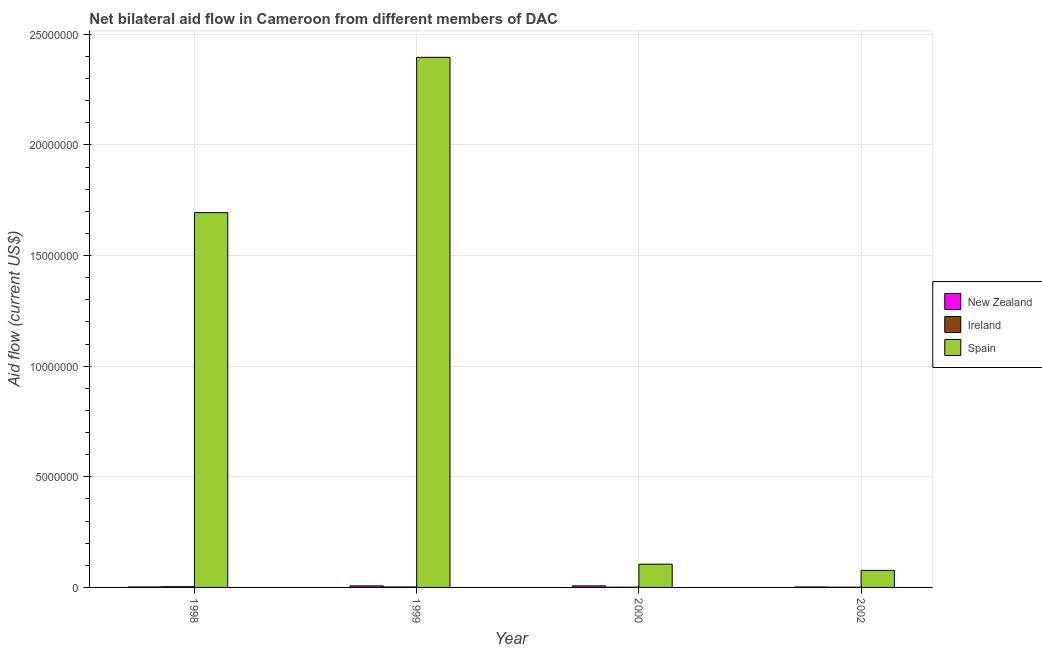How many different coloured bars are there?
Your answer should be compact. 3. How many bars are there on the 4th tick from the left?
Your answer should be compact. 3. In how many cases, is the number of bars for a given year not equal to the number of legend labels?
Your answer should be very brief. 0. What is the amount of aid provided by new zealand in 2000?
Keep it short and to the point. 7.00e+04. Across all years, what is the maximum amount of aid provided by new zealand?
Make the answer very short. 7.00e+04. Across all years, what is the minimum amount of aid provided by ireland?
Keep it short and to the point. 10000. In which year was the amount of aid provided by spain maximum?
Offer a terse response. 1999. What is the total amount of aid provided by new zealand in the graph?
Provide a succinct answer. 1.80e+05. What is the difference between the amount of aid provided by ireland in 2000 and that in 2002?
Keep it short and to the point. 0. What is the difference between the amount of aid provided by ireland in 1999 and the amount of aid provided by new zealand in 2002?
Your response must be concise. 10000. What is the average amount of aid provided by spain per year?
Provide a succinct answer. 1.07e+07. In the year 1998, what is the difference between the amount of aid provided by ireland and amount of aid provided by new zealand?
Ensure brevity in your answer.  0. In how many years, is the amount of aid provided by new zealand greater than 1000000 US$?
Your answer should be compact. 0. What is the ratio of the amount of aid provided by spain in 1998 to that in 2002?
Provide a short and direct response. 22. What is the difference between the highest and the lowest amount of aid provided by new zealand?
Provide a succinct answer. 5.00e+04. In how many years, is the amount of aid provided by new zealand greater than the average amount of aid provided by new zealand taken over all years?
Offer a terse response. 2. Is the sum of the amount of aid provided by ireland in 1999 and 2000 greater than the maximum amount of aid provided by spain across all years?
Your answer should be very brief. No. What does the 1st bar from the left in 1998 represents?
Keep it short and to the point. New Zealand. What does the 1st bar from the right in 2002 represents?
Ensure brevity in your answer.  Spain. Is it the case that in every year, the sum of the amount of aid provided by new zealand and amount of aid provided by ireland is greater than the amount of aid provided by spain?
Ensure brevity in your answer.  No. Are all the bars in the graph horizontal?
Your answer should be very brief. No. What is the difference between two consecutive major ticks on the Y-axis?
Your answer should be very brief. 5.00e+06. Are the values on the major ticks of Y-axis written in scientific E-notation?
Your answer should be compact. No. Where does the legend appear in the graph?
Provide a succinct answer. Center right. What is the title of the graph?
Keep it short and to the point. Net bilateral aid flow in Cameroon from different members of DAC. What is the Aid flow (current US$) in New Zealand in 1998?
Provide a short and direct response. 2.00e+04. What is the Aid flow (current US$) of Spain in 1998?
Offer a terse response. 1.69e+07. What is the Aid flow (current US$) of Ireland in 1999?
Offer a very short reply. 2.00e+04. What is the Aid flow (current US$) of Spain in 1999?
Keep it short and to the point. 2.40e+07. What is the Aid flow (current US$) in New Zealand in 2000?
Provide a short and direct response. 7.00e+04. What is the Aid flow (current US$) in Spain in 2000?
Offer a very short reply. 1.05e+06. What is the Aid flow (current US$) in Spain in 2002?
Your answer should be compact. 7.70e+05. Across all years, what is the maximum Aid flow (current US$) in New Zealand?
Your response must be concise. 7.00e+04. Across all years, what is the maximum Aid flow (current US$) of Ireland?
Ensure brevity in your answer.  3.00e+04. Across all years, what is the maximum Aid flow (current US$) in Spain?
Offer a very short reply. 2.40e+07. Across all years, what is the minimum Aid flow (current US$) of New Zealand?
Your response must be concise. 2.00e+04. Across all years, what is the minimum Aid flow (current US$) in Spain?
Provide a short and direct response. 7.70e+05. What is the total Aid flow (current US$) in New Zealand in the graph?
Keep it short and to the point. 1.80e+05. What is the total Aid flow (current US$) in Spain in the graph?
Give a very brief answer. 4.27e+07. What is the difference between the Aid flow (current US$) of New Zealand in 1998 and that in 1999?
Your response must be concise. -5.00e+04. What is the difference between the Aid flow (current US$) in Ireland in 1998 and that in 1999?
Your response must be concise. 10000. What is the difference between the Aid flow (current US$) of Spain in 1998 and that in 1999?
Ensure brevity in your answer.  -7.02e+06. What is the difference between the Aid flow (current US$) of New Zealand in 1998 and that in 2000?
Provide a succinct answer. -5.00e+04. What is the difference between the Aid flow (current US$) of Ireland in 1998 and that in 2000?
Provide a succinct answer. 2.00e+04. What is the difference between the Aid flow (current US$) of Spain in 1998 and that in 2000?
Keep it short and to the point. 1.59e+07. What is the difference between the Aid flow (current US$) of Spain in 1998 and that in 2002?
Offer a very short reply. 1.62e+07. What is the difference between the Aid flow (current US$) of Ireland in 1999 and that in 2000?
Your answer should be very brief. 10000. What is the difference between the Aid flow (current US$) of Spain in 1999 and that in 2000?
Provide a short and direct response. 2.29e+07. What is the difference between the Aid flow (current US$) in New Zealand in 1999 and that in 2002?
Your answer should be compact. 5.00e+04. What is the difference between the Aid flow (current US$) in Spain in 1999 and that in 2002?
Your answer should be compact. 2.32e+07. What is the difference between the Aid flow (current US$) in Ireland in 2000 and that in 2002?
Provide a succinct answer. 0. What is the difference between the Aid flow (current US$) of Spain in 2000 and that in 2002?
Ensure brevity in your answer.  2.80e+05. What is the difference between the Aid flow (current US$) in New Zealand in 1998 and the Aid flow (current US$) in Ireland in 1999?
Offer a terse response. 0. What is the difference between the Aid flow (current US$) in New Zealand in 1998 and the Aid flow (current US$) in Spain in 1999?
Give a very brief answer. -2.39e+07. What is the difference between the Aid flow (current US$) of Ireland in 1998 and the Aid flow (current US$) of Spain in 1999?
Keep it short and to the point. -2.39e+07. What is the difference between the Aid flow (current US$) in New Zealand in 1998 and the Aid flow (current US$) in Ireland in 2000?
Provide a short and direct response. 10000. What is the difference between the Aid flow (current US$) in New Zealand in 1998 and the Aid flow (current US$) in Spain in 2000?
Keep it short and to the point. -1.03e+06. What is the difference between the Aid flow (current US$) in Ireland in 1998 and the Aid flow (current US$) in Spain in 2000?
Offer a terse response. -1.02e+06. What is the difference between the Aid flow (current US$) in New Zealand in 1998 and the Aid flow (current US$) in Spain in 2002?
Your answer should be very brief. -7.50e+05. What is the difference between the Aid flow (current US$) in Ireland in 1998 and the Aid flow (current US$) in Spain in 2002?
Give a very brief answer. -7.40e+05. What is the difference between the Aid flow (current US$) of New Zealand in 1999 and the Aid flow (current US$) of Ireland in 2000?
Your response must be concise. 6.00e+04. What is the difference between the Aid flow (current US$) in New Zealand in 1999 and the Aid flow (current US$) in Spain in 2000?
Ensure brevity in your answer.  -9.80e+05. What is the difference between the Aid flow (current US$) of Ireland in 1999 and the Aid flow (current US$) of Spain in 2000?
Ensure brevity in your answer.  -1.03e+06. What is the difference between the Aid flow (current US$) in New Zealand in 1999 and the Aid flow (current US$) in Spain in 2002?
Your answer should be compact. -7.00e+05. What is the difference between the Aid flow (current US$) of Ireland in 1999 and the Aid flow (current US$) of Spain in 2002?
Your answer should be compact. -7.50e+05. What is the difference between the Aid flow (current US$) of New Zealand in 2000 and the Aid flow (current US$) of Ireland in 2002?
Your answer should be very brief. 6.00e+04. What is the difference between the Aid flow (current US$) in New Zealand in 2000 and the Aid flow (current US$) in Spain in 2002?
Your response must be concise. -7.00e+05. What is the difference between the Aid flow (current US$) in Ireland in 2000 and the Aid flow (current US$) in Spain in 2002?
Offer a very short reply. -7.60e+05. What is the average Aid flow (current US$) in New Zealand per year?
Provide a succinct answer. 4.50e+04. What is the average Aid flow (current US$) of Ireland per year?
Your answer should be very brief. 1.75e+04. What is the average Aid flow (current US$) in Spain per year?
Your answer should be compact. 1.07e+07. In the year 1998, what is the difference between the Aid flow (current US$) of New Zealand and Aid flow (current US$) of Ireland?
Provide a short and direct response. -10000. In the year 1998, what is the difference between the Aid flow (current US$) in New Zealand and Aid flow (current US$) in Spain?
Ensure brevity in your answer.  -1.69e+07. In the year 1998, what is the difference between the Aid flow (current US$) in Ireland and Aid flow (current US$) in Spain?
Provide a succinct answer. -1.69e+07. In the year 1999, what is the difference between the Aid flow (current US$) in New Zealand and Aid flow (current US$) in Ireland?
Your answer should be compact. 5.00e+04. In the year 1999, what is the difference between the Aid flow (current US$) of New Zealand and Aid flow (current US$) of Spain?
Your answer should be very brief. -2.39e+07. In the year 1999, what is the difference between the Aid flow (current US$) of Ireland and Aid flow (current US$) of Spain?
Offer a very short reply. -2.39e+07. In the year 2000, what is the difference between the Aid flow (current US$) in New Zealand and Aid flow (current US$) in Ireland?
Your answer should be compact. 6.00e+04. In the year 2000, what is the difference between the Aid flow (current US$) in New Zealand and Aid flow (current US$) in Spain?
Make the answer very short. -9.80e+05. In the year 2000, what is the difference between the Aid flow (current US$) of Ireland and Aid flow (current US$) of Spain?
Offer a very short reply. -1.04e+06. In the year 2002, what is the difference between the Aid flow (current US$) in New Zealand and Aid flow (current US$) in Spain?
Offer a terse response. -7.50e+05. In the year 2002, what is the difference between the Aid flow (current US$) of Ireland and Aid flow (current US$) of Spain?
Make the answer very short. -7.60e+05. What is the ratio of the Aid flow (current US$) in New Zealand in 1998 to that in 1999?
Make the answer very short. 0.29. What is the ratio of the Aid flow (current US$) in Ireland in 1998 to that in 1999?
Keep it short and to the point. 1.5. What is the ratio of the Aid flow (current US$) in Spain in 1998 to that in 1999?
Your answer should be very brief. 0.71. What is the ratio of the Aid flow (current US$) of New Zealand in 1998 to that in 2000?
Give a very brief answer. 0.29. What is the ratio of the Aid flow (current US$) of Ireland in 1998 to that in 2000?
Offer a terse response. 3. What is the ratio of the Aid flow (current US$) of Spain in 1998 to that in 2000?
Provide a short and direct response. 16.13. What is the ratio of the Aid flow (current US$) of New Zealand in 1998 to that in 2002?
Provide a short and direct response. 1. What is the ratio of the Aid flow (current US$) in Ireland in 1998 to that in 2002?
Ensure brevity in your answer.  3. What is the ratio of the Aid flow (current US$) of Ireland in 1999 to that in 2000?
Offer a very short reply. 2. What is the ratio of the Aid flow (current US$) of Spain in 1999 to that in 2000?
Ensure brevity in your answer.  22.82. What is the ratio of the Aid flow (current US$) of Spain in 1999 to that in 2002?
Give a very brief answer. 31.12. What is the ratio of the Aid flow (current US$) in New Zealand in 2000 to that in 2002?
Ensure brevity in your answer.  3.5. What is the ratio of the Aid flow (current US$) of Ireland in 2000 to that in 2002?
Your answer should be compact. 1. What is the ratio of the Aid flow (current US$) in Spain in 2000 to that in 2002?
Your response must be concise. 1.36. What is the difference between the highest and the second highest Aid flow (current US$) of New Zealand?
Make the answer very short. 0. What is the difference between the highest and the second highest Aid flow (current US$) of Ireland?
Your response must be concise. 10000. What is the difference between the highest and the second highest Aid flow (current US$) in Spain?
Provide a succinct answer. 7.02e+06. What is the difference between the highest and the lowest Aid flow (current US$) in New Zealand?
Keep it short and to the point. 5.00e+04. What is the difference between the highest and the lowest Aid flow (current US$) of Spain?
Ensure brevity in your answer.  2.32e+07. 